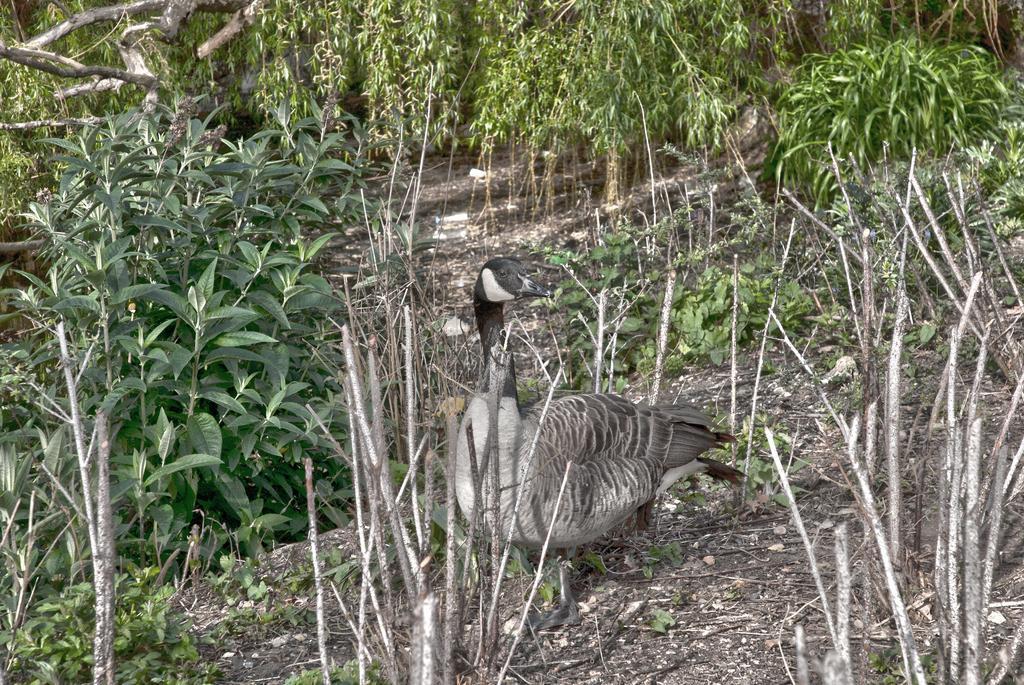Could you give a brief overview of what you see in this image? In this image there is a bird, there are plants. 